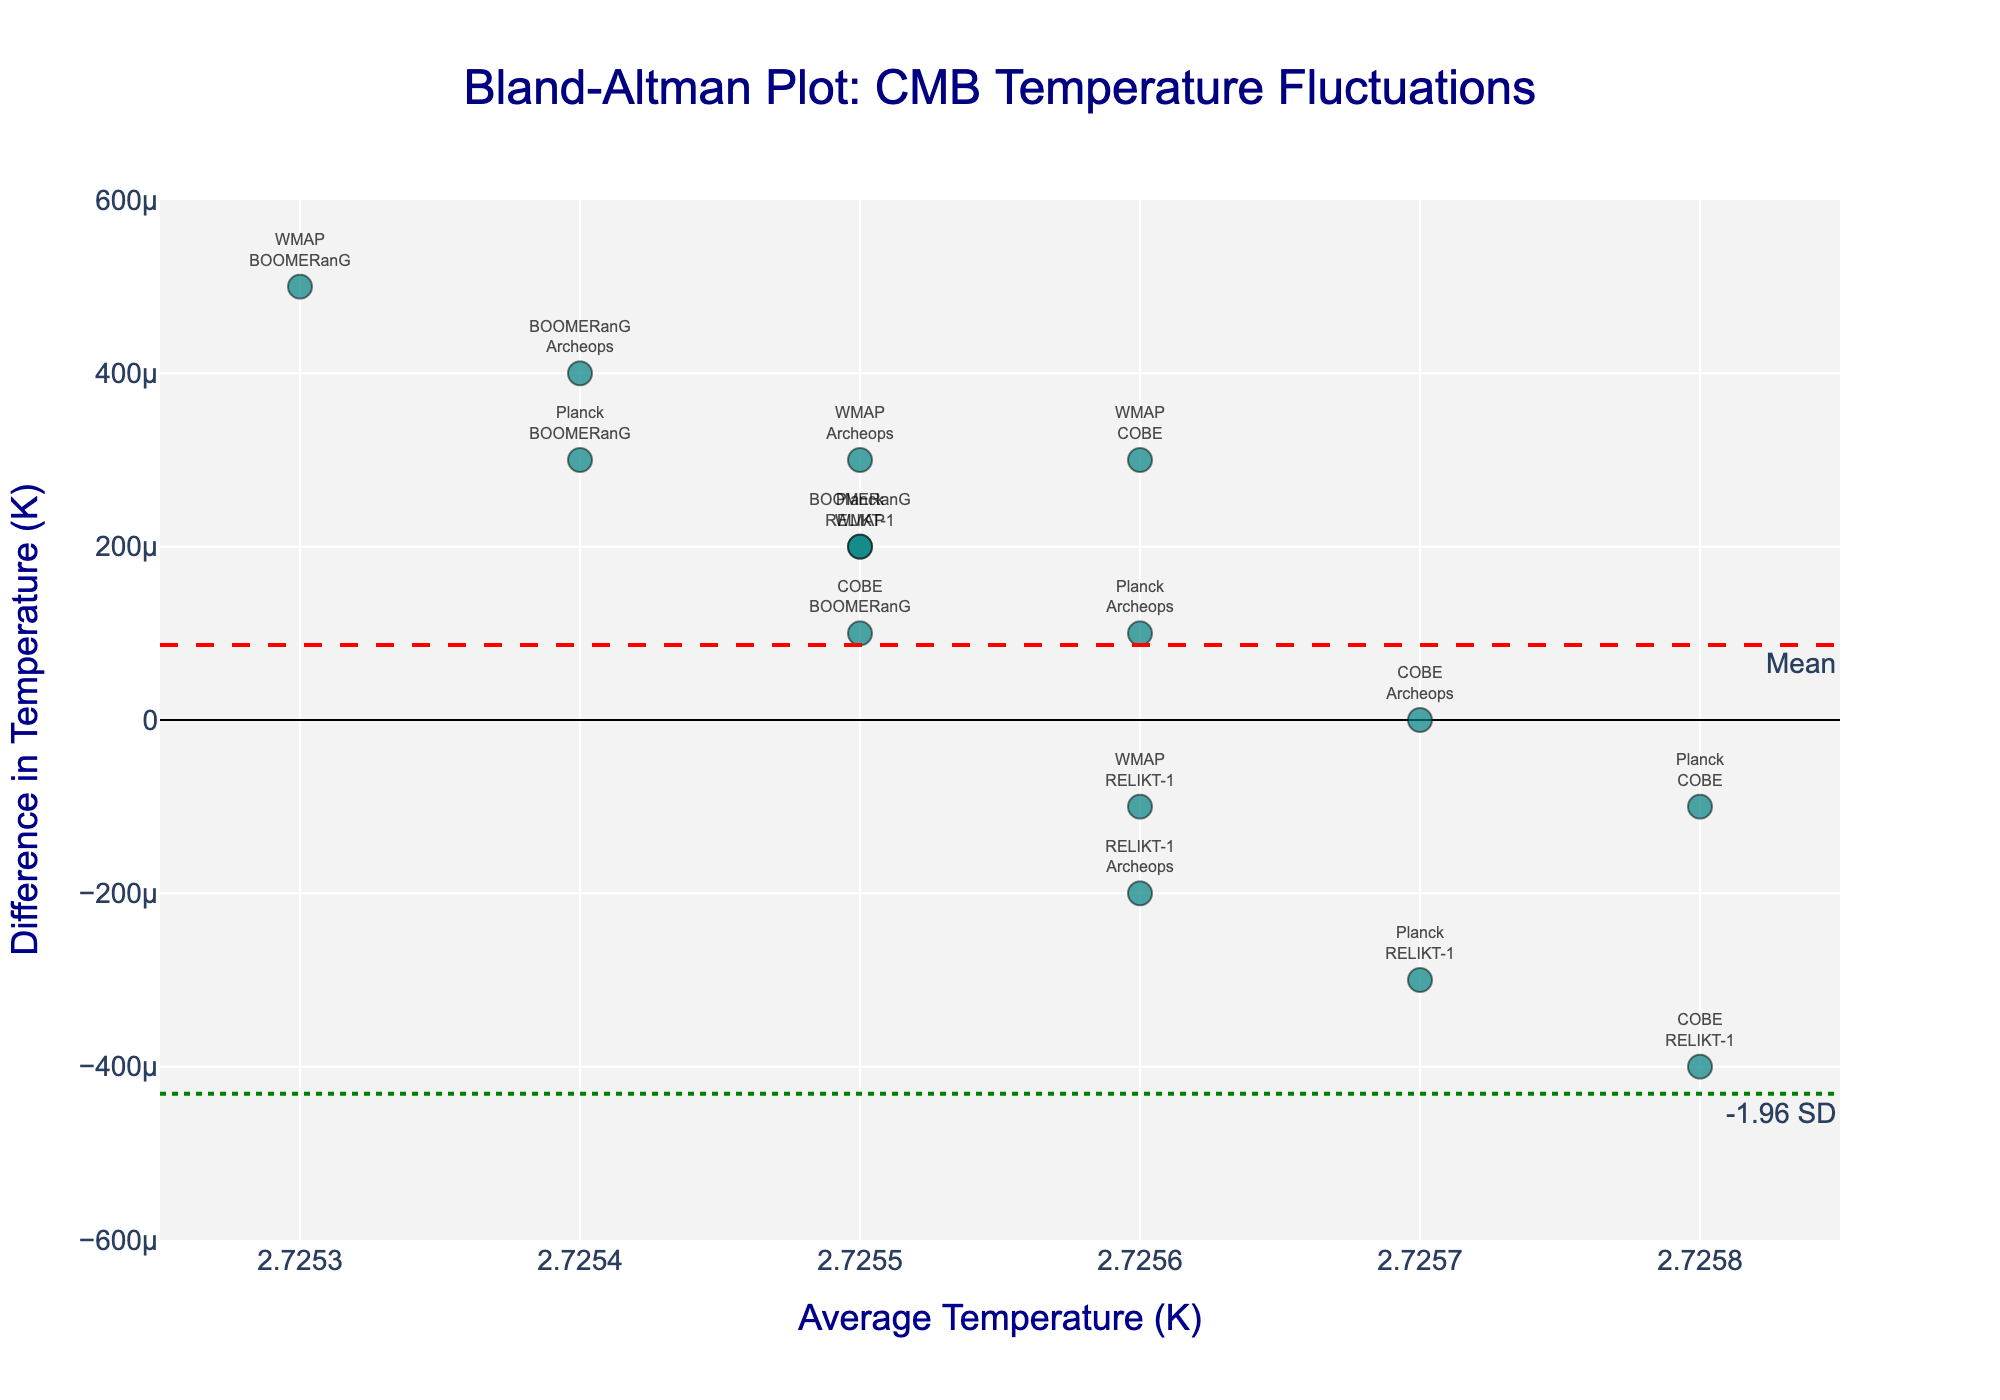What is the title of the plot? The title of the plot is usually displayed at the top. In this case, it reads "Bland-Altman Plot: CMB Temperature Fluctuations".
Answer: Bland-Altman Plot: CMB Temperature Fluctuations What are the x-axis and y-axis labels? The x-axis label is usually positioned below the axis and the y-axis label is positioned along the side of the axis. Here, the x-axis label reads "Average Temperature (K)" and the y-axis label reads "Difference in Temperature (K)".
Answer: Average Temperature (K), Difference in Temperature (K) How many data points are there in the plot? Data points are represented by markers. Each marker corresponds to a pair of telescope measurements as indicated by the text labels next to each marker. Counting them, there are 15 points.
Answer: 15 What color are the data points in the scatter plot? The color of the data points can be observed directly by looking at the points in the plot. They are a shade of teal.
Answer: Teal Which telescope pairs have the largest positive difference in temperature? The largest positive difference can be found by observing which marker is the highest on the y-axis. The pair label closest to this marker is "WMAP<br>BOOMERanG".
Answer: WMAP, BOOMERanG What is the mean difference in temperature between the telescope measurements? The mean difference is represented by a horizontal dashed line in red. It is also labeled "Mean". The value marked on the y-axis for this line is 0.0001 K.
Answer: 0.0001 K What is the standard deviation range for the difference in temperature? The standard deviation range is indicated by the horizontal dotted green lines marked as "+1.96 SD" and "-1.96 SD". Observing where these lines intersect the y-axis, they are at approximately 0.0005 K and -0.0003 K.
Answer: 0.0004 K Which telescope pairs fall within the 95% agreement limits? Points within the 95% limits will be between the green dotted lines at +1.96 SD and -1.96 SD. Most points fall within this range, such as "Planck<br>WMAP", "Planck<br>COBE", "WMAP<br>COBE", among others.
Answer: Multiple pairs including Planck-WMAP, Planck-COBE, WMAP-COBE Do any telescope pairs fall outside the 95% limits? Points falling outside the 95% limits will be beyond the green dotted lines. Observing the plot, none of the data points exceed these limits, suggesting all telescope pairs are within the limits.
Answer: No What is the smallest difference in temperature observed? The smallest difference can be found by looking at the marker closest to the x-axis (y=0). The point closest to zero is "COBE<br>Archeops" which has a difference of 0.0 K.
Answer: 0.0 K 